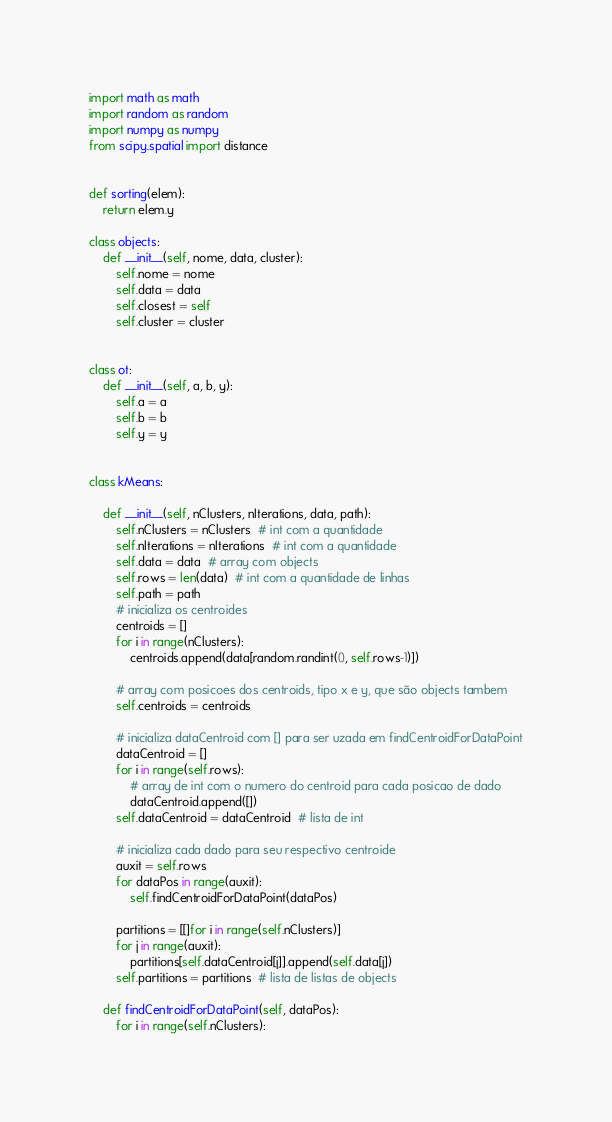<code> <loc_0><loc_0><loc_500><loc_500><_Python_>import math as math
import random as random
import numpy as numpy
from scipy.spatial import distance


def sorting(elem):
    return elem.y

class objects:
    def __init__(self, nome, data, cluster):
        self.nome = nome
        self.data = data
        self.closest = self
        self.cluster = cluster


class ot:
    def __init__(self, a, b, y):
        self.a = a
        self.b = b
        self.y = y


class kMeans:

    def __init__(self, nClusters, nIterations, data, path):
        self.nClusters = nClusters  # int com a quantidade
        self.nIterations = nIterations  # int com a quantidade
        self.data = data  # array com objects
        self.rows = len(data)  # int com a quantidade de linhas
        self.path = path
        # inicializa os centroides
        centroids = []
        for i in range(nClusters):
            centroids.append(data[random.randint(0, self.rows-1)])

        # array com posicoes dos centroids, tipo x e y, que são objects tambem
        self.centroids = centroids

        # inicializa dataCentroid com [] para ser uzada em findCentroidForDataPoint
        dataCentroid = []
        for i in range(self.rows):
            # array de int com o numero do centroid para cada posicao de dado
            dataCentroid.append([])
        self.dataCentroid = dataCentroid  # lista de int

        # inicializa cada dado para seu respectivo centroide
        auxit = self.rows
        for dataPos in range(auxit):
            self.findCentroidForDataPoint(dataPos)

        partitions = [[]for i in range(self.nClusters)]
        for j in range(auxit):
            partitions[self.dataCentroid[j]].append(self.data[j])
        self.partitions = partitions  # lista de listas de objects

    def findCentroidForDataPoint(self, dataPos):
        for i in range(self.nClusters):</code> 